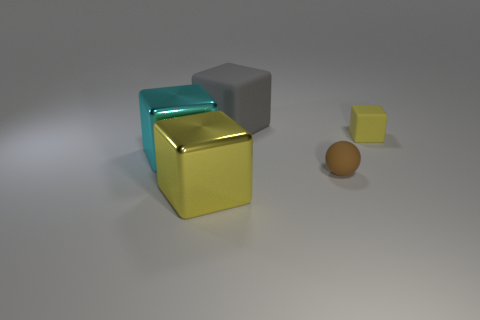Subtract all cyan cubes. How many cubes are left? 3 Add 4 tiny rubber objects. How many objects exist? 9 Subtract 4 blocks. How many blocks are left? 0 Subtract all cyan cubes. How many cubes are left? 3 Subtract all blocks. How many objects are left? 1 Add 4 yellow cubes. How many yellow cubes are left? 6 Add 3 small matte cubes. How many small matte cubes exist? 4 Subtract 0 gray spheres. How many objects are left? 5 Subtract all red cubes. Subtract all red cylinders. How many cubes are left? 4 Subtract all blue cylinders. How many gray cubes are left? 1 